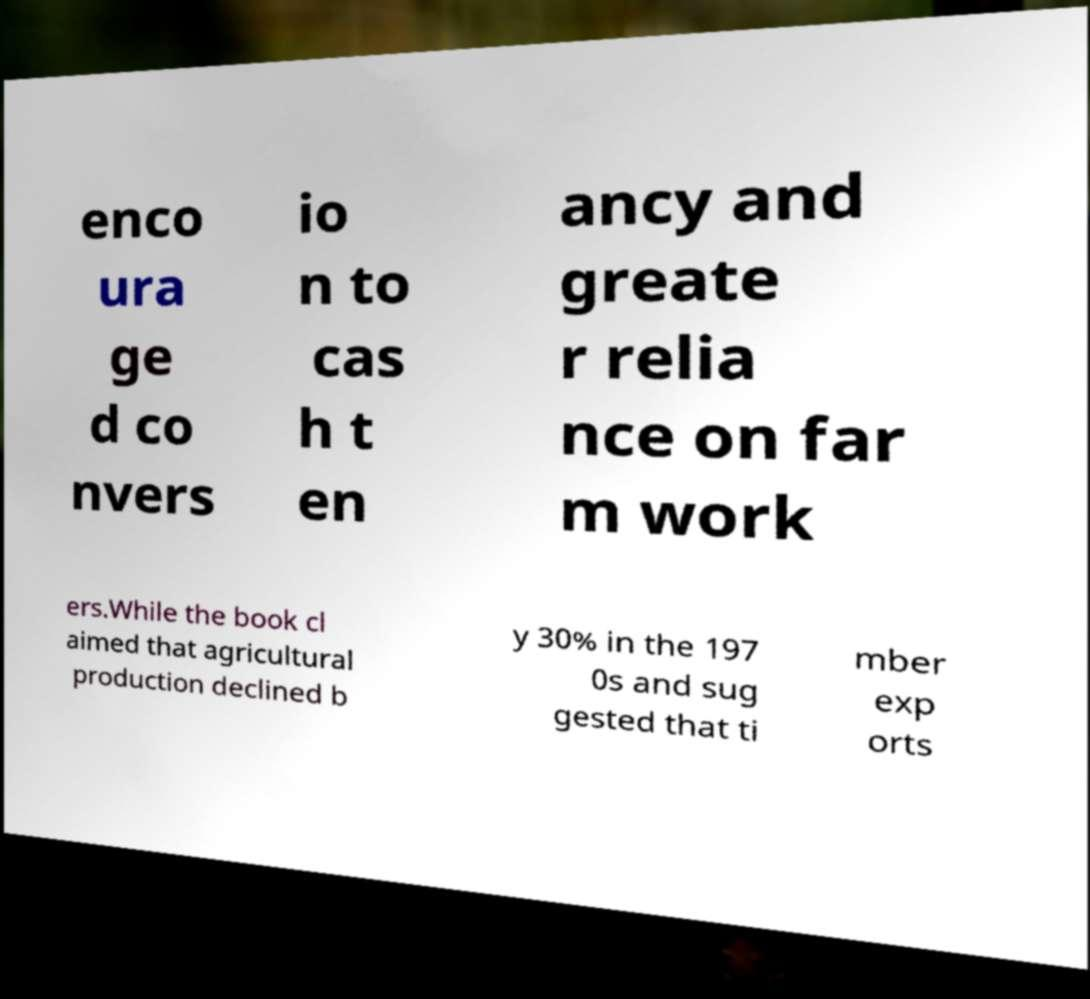There's text embedded in this image that I need extracted. Can you transcribe it verbatim? enco ura ge d co nvers io n to cas h t en ancy and greate r relia nce on far m work ers.While the book cl aimed that agricultural production declined b y 30% in the 197 0s and sug gested that ti mber exp orts 